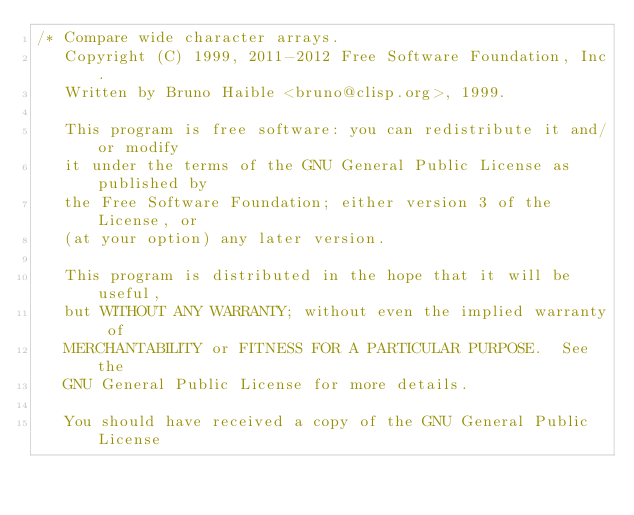Convert code to text. <code><loc_0><loc_0><loc_500><loc_500><_C_>/* Compare wide character arrays.
   Copyright (C) 1999, 2011-2012 Free Software Foundation, Inc.
   Written by Bruno Haible <bruno@clisp.org>, 1999.

   This program is free software: you can redistribute it and/or modify
   it under the terms of the GNU General Public License as published by
   the Free Software Foundation; either version 3 of the License, or
   (at your option) any later version.

   This program is distributed in the hope that it will be useful,
   but WITHOUT ANY WARRANTY; without even the implied warranty of
   MERCHANTABILITY or FITNESS FOR A PARTICULAR PURPOSE.  See the
   GNU General Public License for more details.

   You should have received a copy of the GNU General Public License</code> 